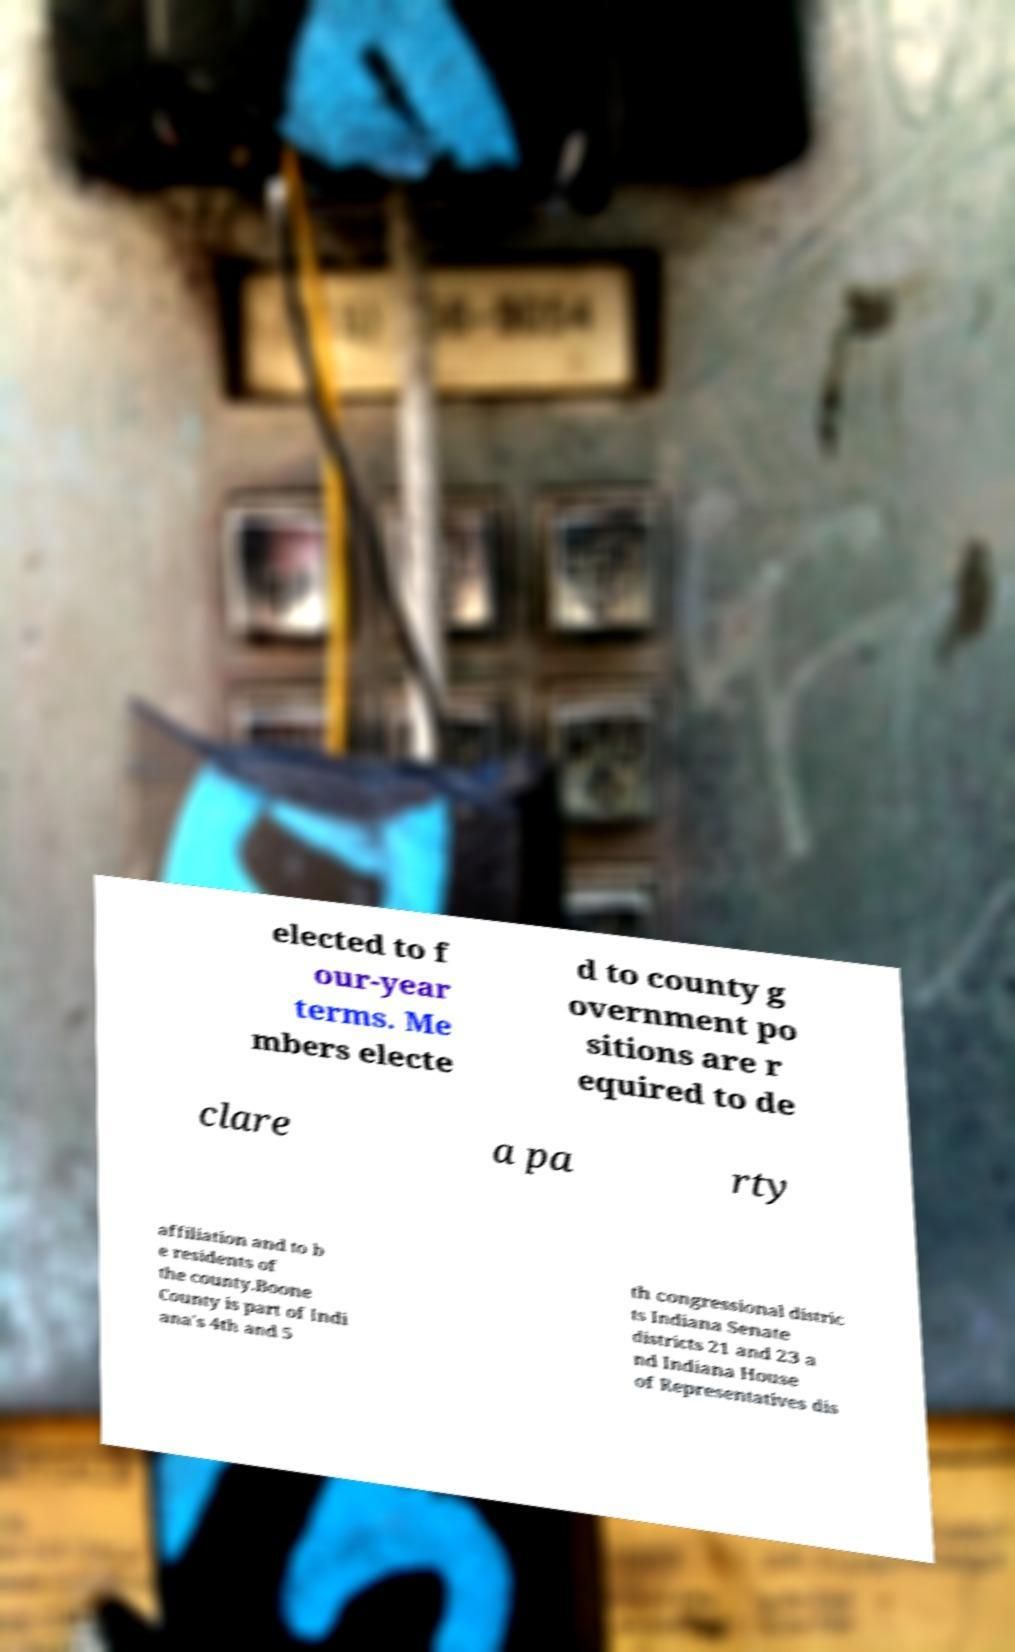Could you assist in decoding the text presented in this image and type it out clearly? elected to f our-year terms. Me mbers electe d to county g overnment po sitions are r equired to de clare a pa rty affiliation and to b e residents of the county.Boone County is part of Indi ana's 4th and 5 th congressional distric ts Indiana Senate districts 21 and 23 a nd Indiana House of Representatives dis 